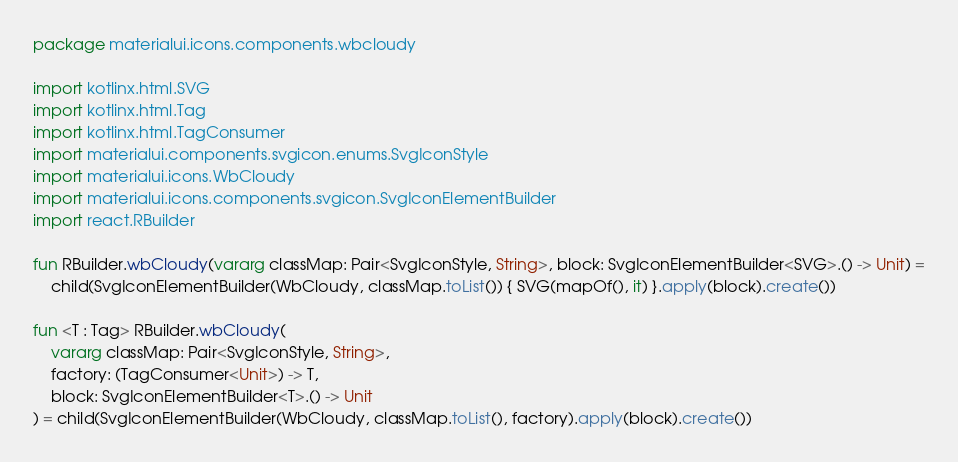Convert code to text. <code><loc_0><loc_0><loc_500><loc_500><_Kotlin_>package materialui.icons.components.wbcloudy

import kotlinx.html.SVG
import kotlinx.html.Tag
import kotlinx.html.TagConsumer
import materialui.components.svgicon.enums.SvgIconStyle
import materialui.icons.WbCloudy
import materialui.icons.components.svgicon.SvgIconElementBuilder
import react.RBuilder

fun RBuilder.wbCloudy(vararg classMap: Pair<SvgIconStyle, String>, block: SvgIconElementBuilder<SVG>.() -> Unit) =
    child(SvgIconElementBuilder(WbCloudy, classMap.toList()) { SVG(mapOf(), it) }.apply(block).create())

fun <T : Tag> RBuilder.wbCloudy(
    vararg classMap: Pair<SvgIconStyle, String>,
    factory: (TagConsumer<Unit>) -> T,
    block: SvgIconElementBuilder<T>.() -> Unit
) = child(SvgIconElementBuilder(WbCloudy, classMap.toList(), factory).apply(block).create())
</code> 